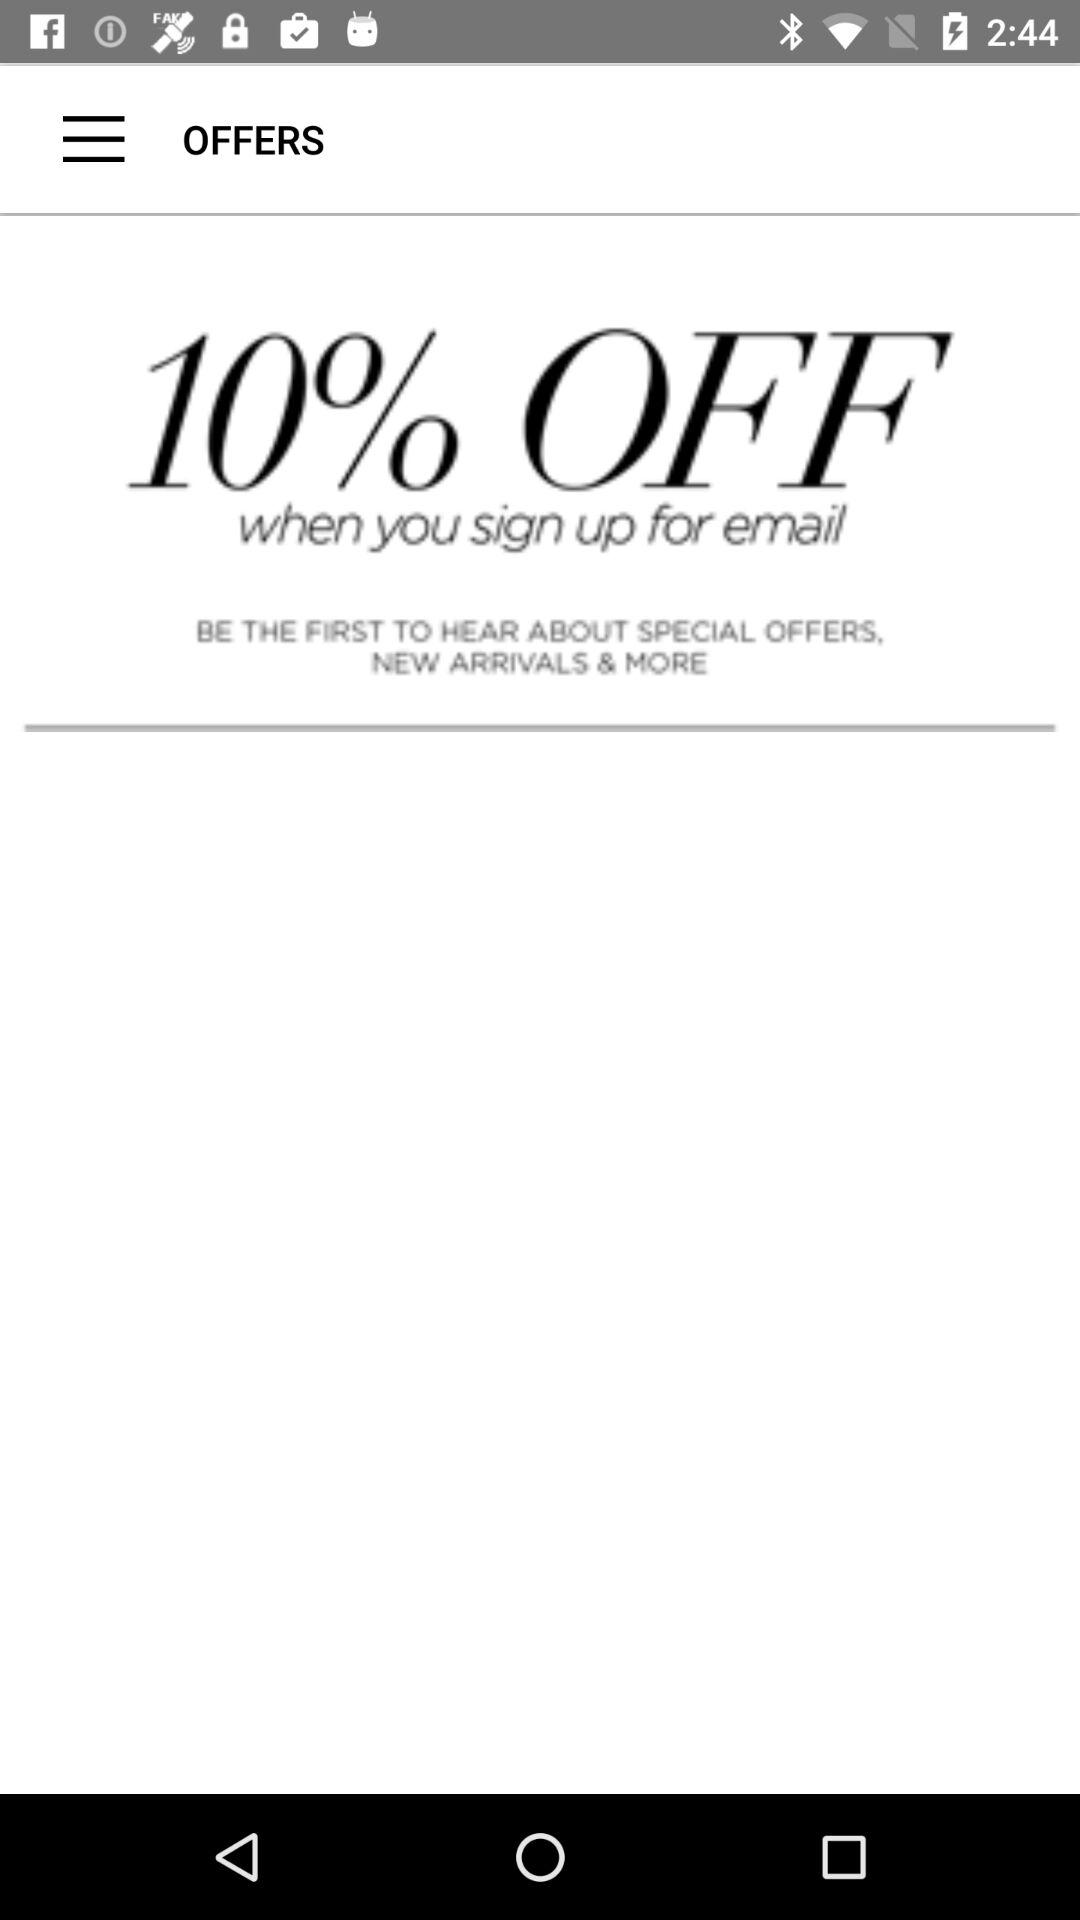How much of a discount will one get for signing up for email? One will get a 10% discount for signing up for email. 